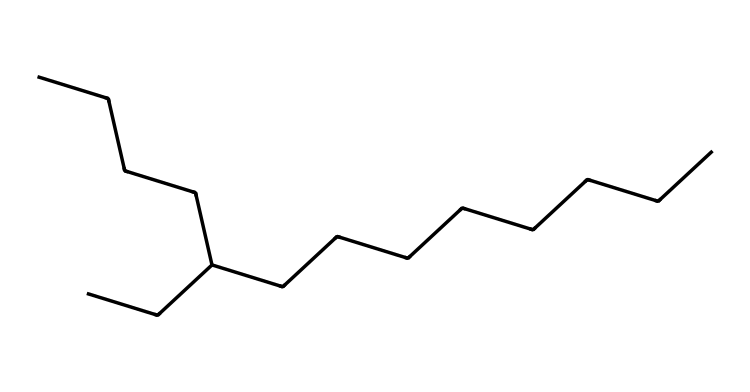What is the total number of carbon atoms in this chemical structure? To determine the total number of carbon atoms, we analyze the SMILES representation and count the "C" characters. Each "C" represents a carbon atom, and in this case, there are 14 carbon atoms in total.
Answer: 14 How many hydrogen atoms are present in this chemical structure? To count the hydrogen atoms, we first count the number of carbon atoms (14) and know that in alkanes, each carbon generally bonds with enough hydrogens to have a total of four bonds. The formula for the number of hydrogen atoms in an alkane is CnH(2n+2). Therefore, with n = 14, H = 2(14)+2 = 30.
Answer: 30 What is the main type of bonding in this chemical structure? The chemical structure primarily contains single covalent bonds between carbon and hydrogen atoms, as it is composed mainly of hydrocarbons (alkane).
Answer: single covalent bonds Is this molecule a saturated or unsaturated lipid? This molecule is an alkane with no double or triple bonds, indicating that it is saturated. Saturated lipids contain only single bonds and are usually solid at room temperature.
Answer: saturated What type of lipid does this structure represent? Given the structure's long carbon chain and the presence of only single bonds, this lipid is identified as a triglyceride or fatty acid, characteristic of many fats and oils.
Answer: triglyceride How many branches are present in the chemical structure? By analyzing the structure, we can see there are additional carbon branches attached to the primary chain. In this specific SMILES notation, one branch (an additional carbon group) is present.
Answer: 1 What is the significance of this structure in aviation fuel? The long-chain hydrocarbons present in this structure allow it to function effectively as an aviation fuel, providing the necessary energy and thermal stability for combustion in jet engines.
Answer: energy source 